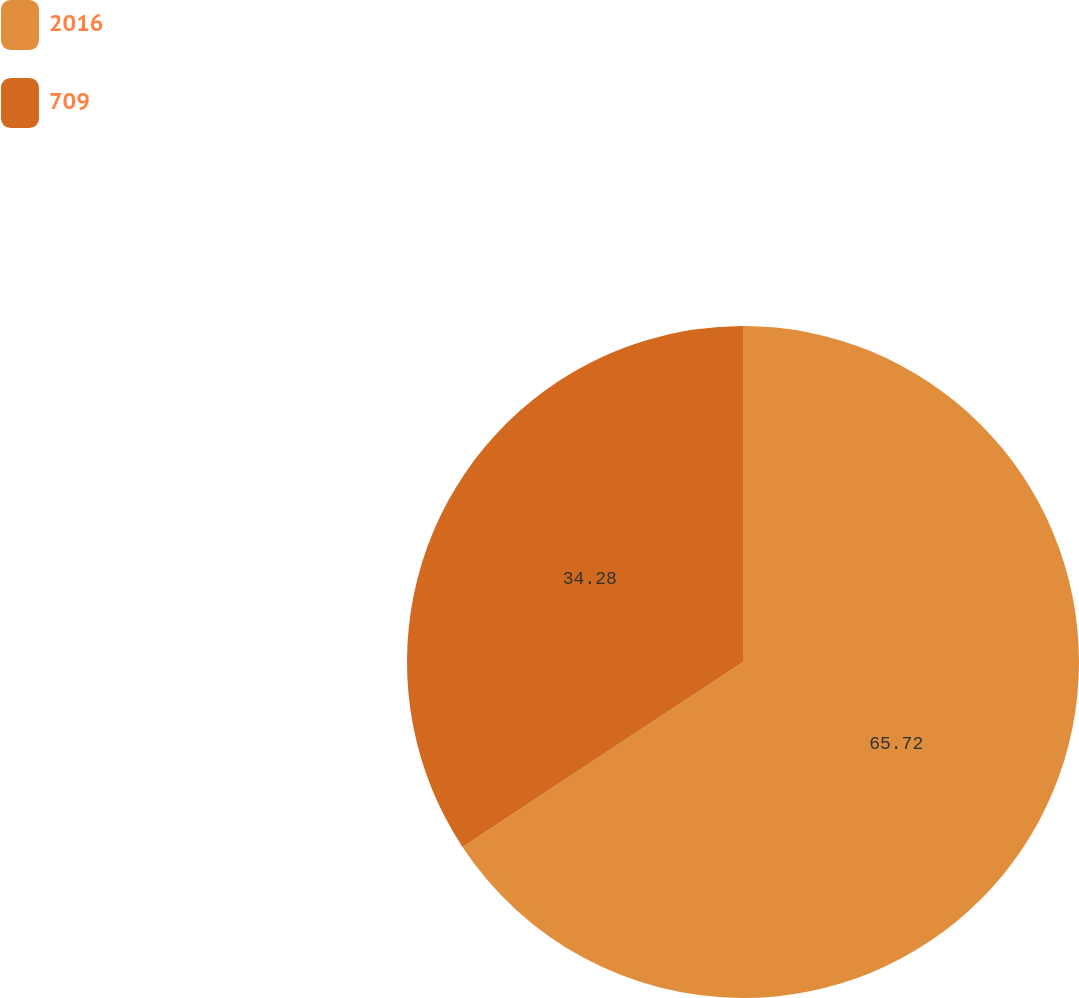Convert chart to OTSL. <chart><loc_0><loc_0><loc_500><loc_500><pie_chart><fcel>2016<fcel>709<nl><fcel>65.72%<fcel>34.28%<nl></chart> 